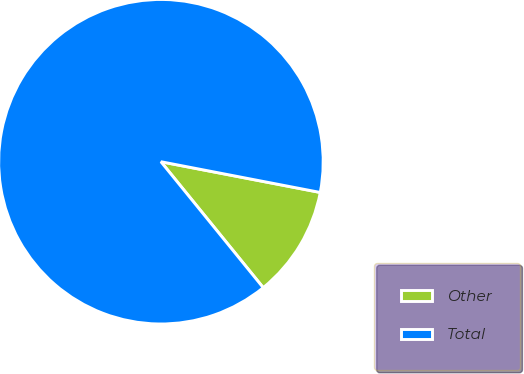Convert chart to OTSL. <chart><loc_0><loc_0><loc_500><loc_500><pie_chart><fcel>Other<fcel>Total<nl><fcel>11.11%<fcel>88.89%<nl></chart> 